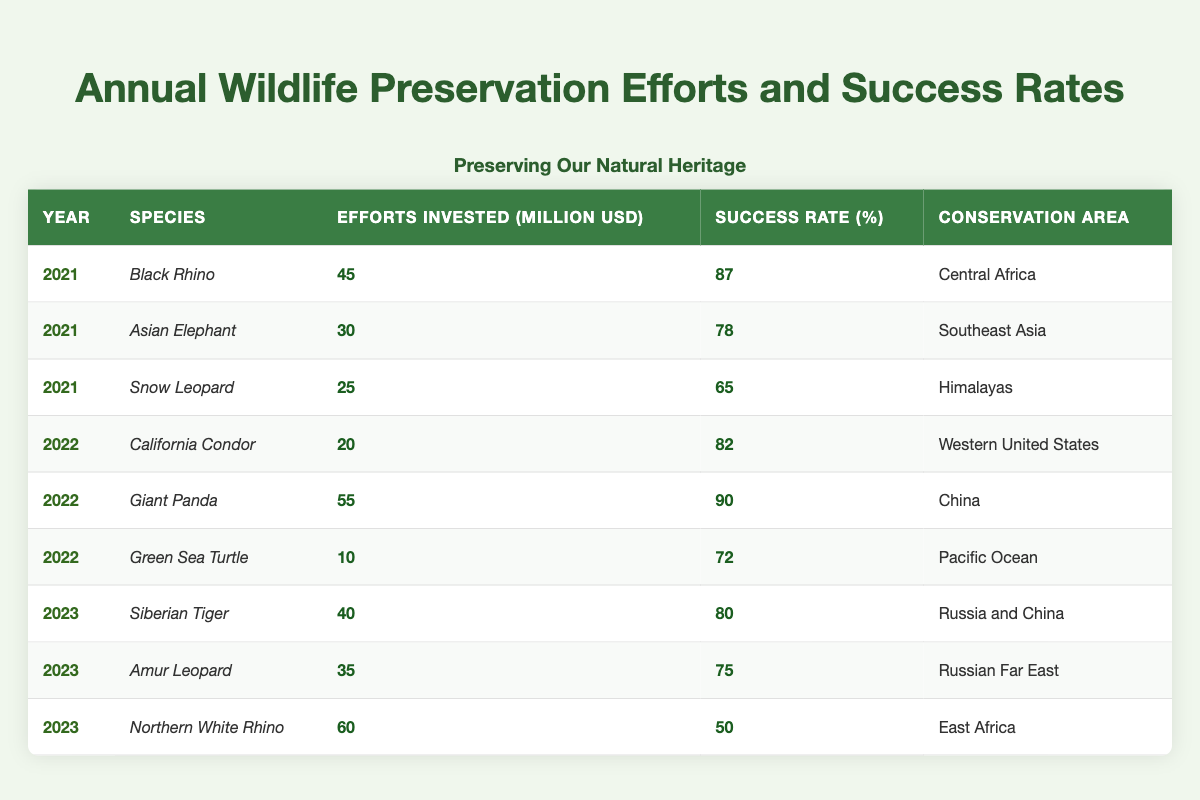What was the success rate for the Giant Panda in 2022? According to the table, the success rate for the Giant Panda in 2022 is **90%**.
Answer: 90% How much was invested in wildlife preservation efforts for the Snow Leopard in 2021? In the table, it states that **25 million USD** was invested for the Snow Leopard in 2021.
Answer: 25 million USD Which species had the highest success rate in 2022? From the table, the Giant Panda had the highest success rate of **90%** in 2022.
Answer: Giant Panda What is the total amount invested in wildlife preservation efforts for all species in 2023? Adding the investments for all species in 2023, (40 + 35 + 60) = **135 million USD**.
Answer: 135 million USD Was the success rate for the Northern White Rhino greater than 60%? The table shows the success rate for the Northern White Rhino is **50%**, which is not greater than 60%.
Answer: No What is the average success rate for all species listed in 2021? The success rates for 2021 are 87%, 78%, and 65%. To find the average, sum them up (87 + 78 + 65 = 230) and divide by 3, resulting in **76.67%**.
Answer: 76.67% Which species had the lowest success rate, and what was it? The Northern White Rhino had the lowest success rate of **50%**, as shown in the table.
Answer: Northern White Rhino, 50% Compare the efforts invested in 2021 and 2022. What was the difference? The total for 2021 is (45 + 30 + 25) = 100 million USD, and for 2022 it is (20 + 55 + 10) = 85 million USD; the difference is 100 - 85 = **15 million USD** more invested in 2021.
Answer: 15 million USD Which conservation area had efforts for the California Condor? The conservation area listed for the California Condor is the **Western United States**.
Answer: Western United States Was there a species with an investment of less than 20 million USD in 2022? The Green Sea Turtle had an investment of **10 million USD**, which is less than 20 million USD.
Answer: Yes 